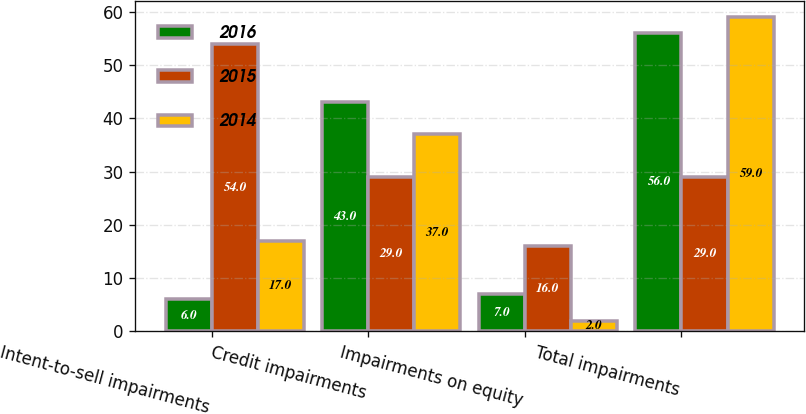Convert chart to OTSL. <chart><loc_0><loc_0><loc_500><loc_500><stacked_bar_chart><ecel><fcel>Intent-to-sell impairments<fcel>Credit impairments<fcel>Impairments on equity<fcel>Total impairments<nl><fcel>2016<fcel>6<fcel>43<fcel>7<fcel>56<nl><fcel>2015<fcel>54<fcel>29<fcel>16<fcel>29<nl><fcel>2014<fcel>17<fcel>37<fcel>2<fcel>59<nl></chart> 